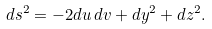Convert formula to latex. <formula><loc_0><loc_0><loc_500><loc_500>d s ^ { 2 } = - 2 d u \, d v + d y ^ { 2 } + d z ^ { 2 } .</formula> 